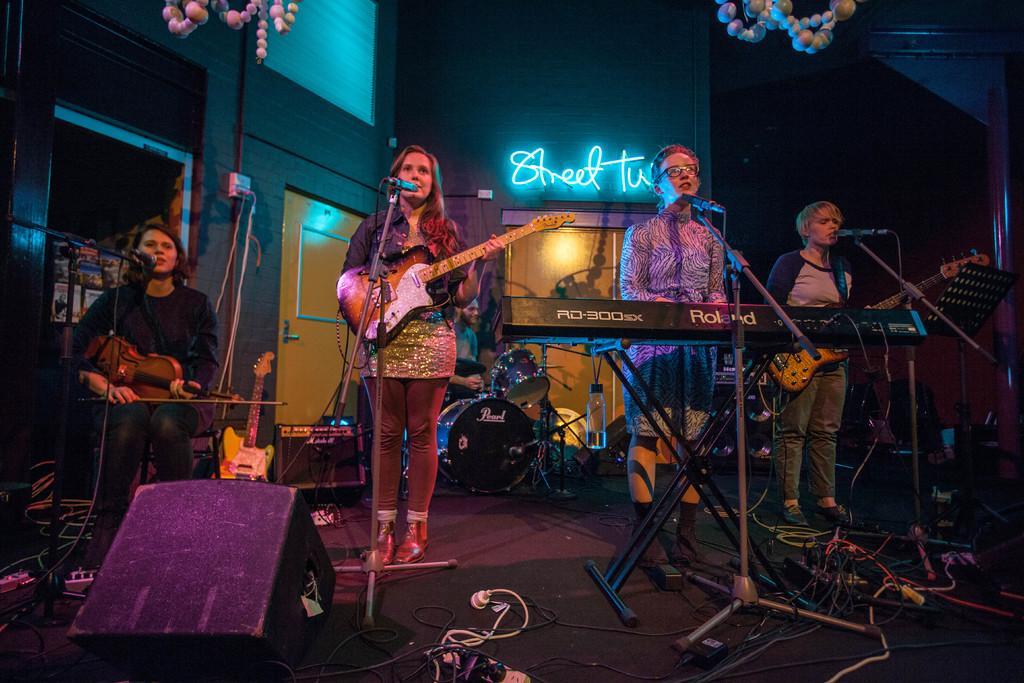Can you describe this image briefly? In the image there are people who are working on the stage. There are four people in which three of them are playing the guitar, while one of them is playing the keyboard. In front of them there is a mic. At the background there is a wall and drums. 